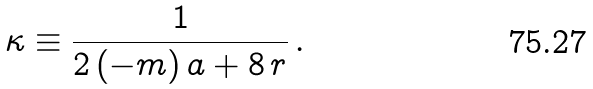Convert formula to latex. <formula><loc_0><loc_0><loc_500><loc_500>\kappa \equiv \frac { 1 } { 2 \, ( - m ) \, a + 8 \, r } \, .</formula> 